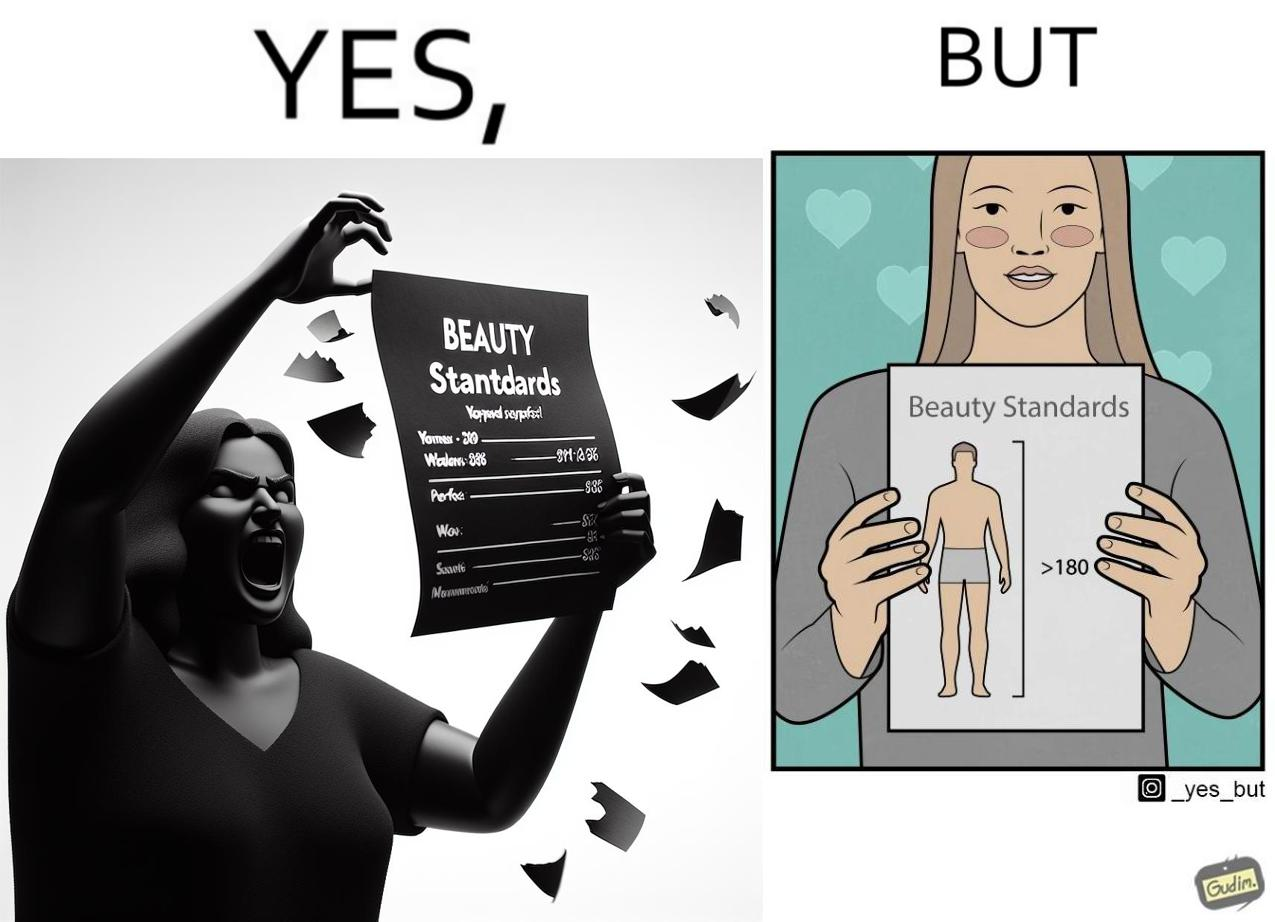What makes this image funny or satirical? The image is ironic because the woman that is angry about having constraints set on the body parts of a woman to be considered beautiful is the same person who is happily presenting contraints on the height of a man to be considered beautiful. 